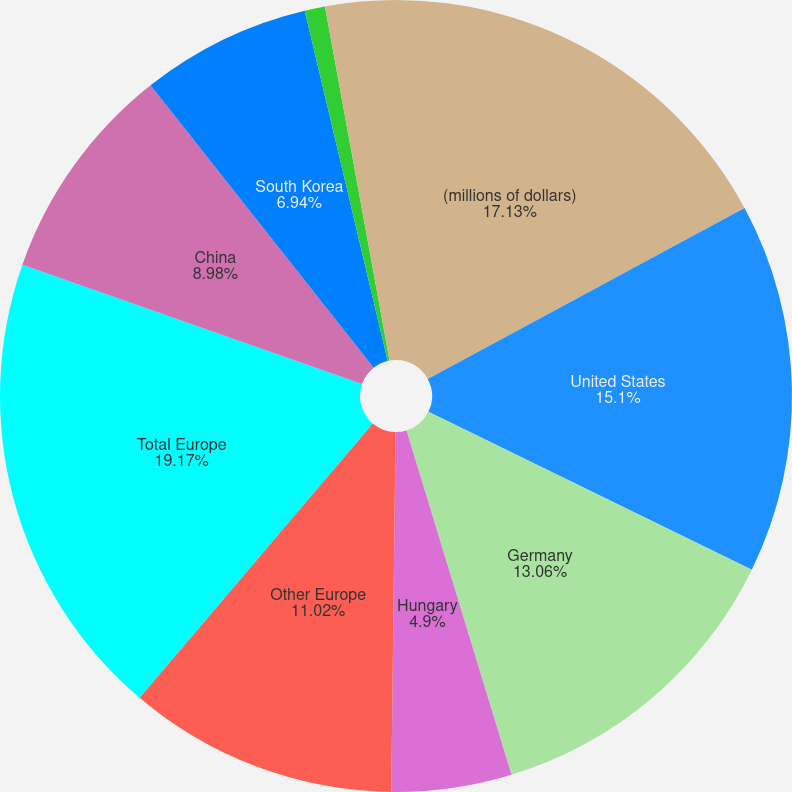Convert chart. <chart><loc_0><loc_0><loc_500><loc_500><pie_chart><fcel>(millions of dollars)<fcel>United States<fcel>Germany<fcel>Hungary<fcel>Other Europe<fcel>Total Europe<fcel>China<fcel>South Korea<fcel>Mexico<fcel>Other foreign<nl><fcel>17.13%<fcel>15.1%<fcel>13.06%<fcel>4.9%<fcel>11.02%<fcel>19.17%<fcel>8.98%<fcel>6.94%<fcel>0.83%<fcel>2.87%<nl></chart> 